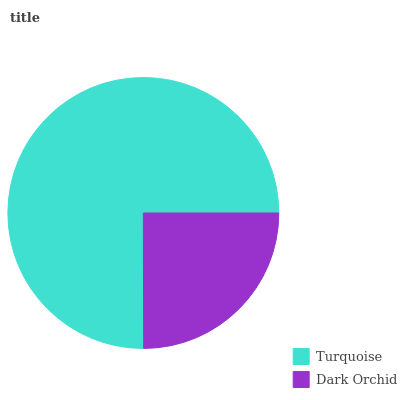Is Dark Orchid the minimum?
Answer yes or no. Yes. Is Turquoise the maximum?
Answer yes or no. Yes. Is Dark Orchid the maximum?
Answer yes or no. No. Is Turquoise greater than Dark Orchid?
Answer yes or no. Yes. Is Dark Orchid less than Turquoise?
Answer yes or no. Yes. Is Dark Orchid greater than Turquoise?
Answer yes or no. No. Is Turquoise less than Dark Orchid?
Answer yes or no. No. Is Turquoise the high median?
Answer yes or no. Yes. Is Dark Orchid the low median?
Answer yes or no. Yes. Is Dark Orchid the high median?
Answer yes or no. No. Is Turquoise the low median?
Answer yes or no. No. 